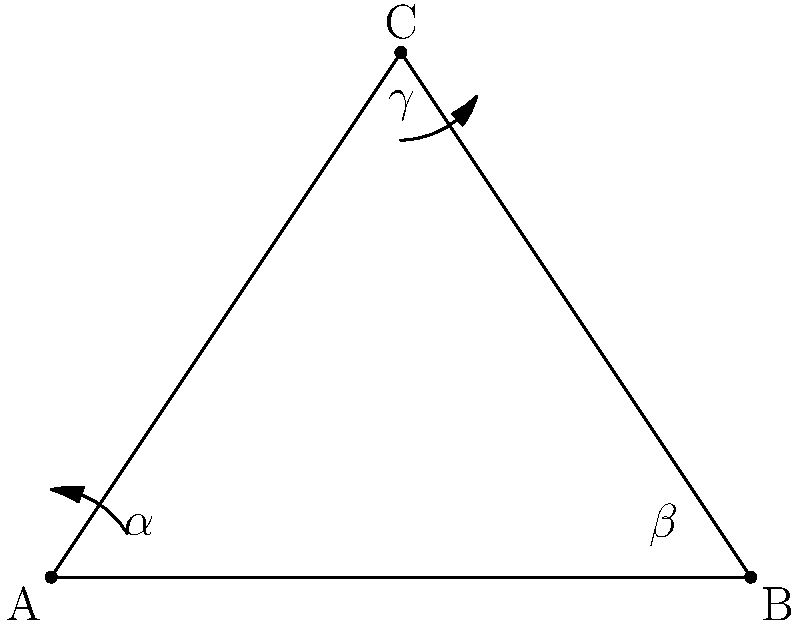During a sculling motion in synchronized swimming, a swimmer's arms form a triangle ABC as shown. If the angle at point C (γ) is 60°, and the angle at point A (α) is 45°, what is the measure of angle β at point B? Let's approach this step-by-step:

1) First, recall the triangle angle sum theorem: the sum of all angles in a triangle is always 180°.

2) We can express this mathematically as:
   
   $\alpha + \beta + \gamma = 180°$

3) We're given two angles:
   $\gamma = 60°$
   $\alpha = 45°$

4) Let's substitute these known values into our equation:
   
   $45° + \beta + 60° = 180°$

5) Simplify:
   
   $105° + \beta = 180°$

6) To solve for $\beta$, subtract 105° from both sides:
   
   $\beta = 180° - 105°$

7) Calculate:
   
   $\beta = 75°$

Therefore, the measure of angle β at point B is 75°.
Answer: 75° 